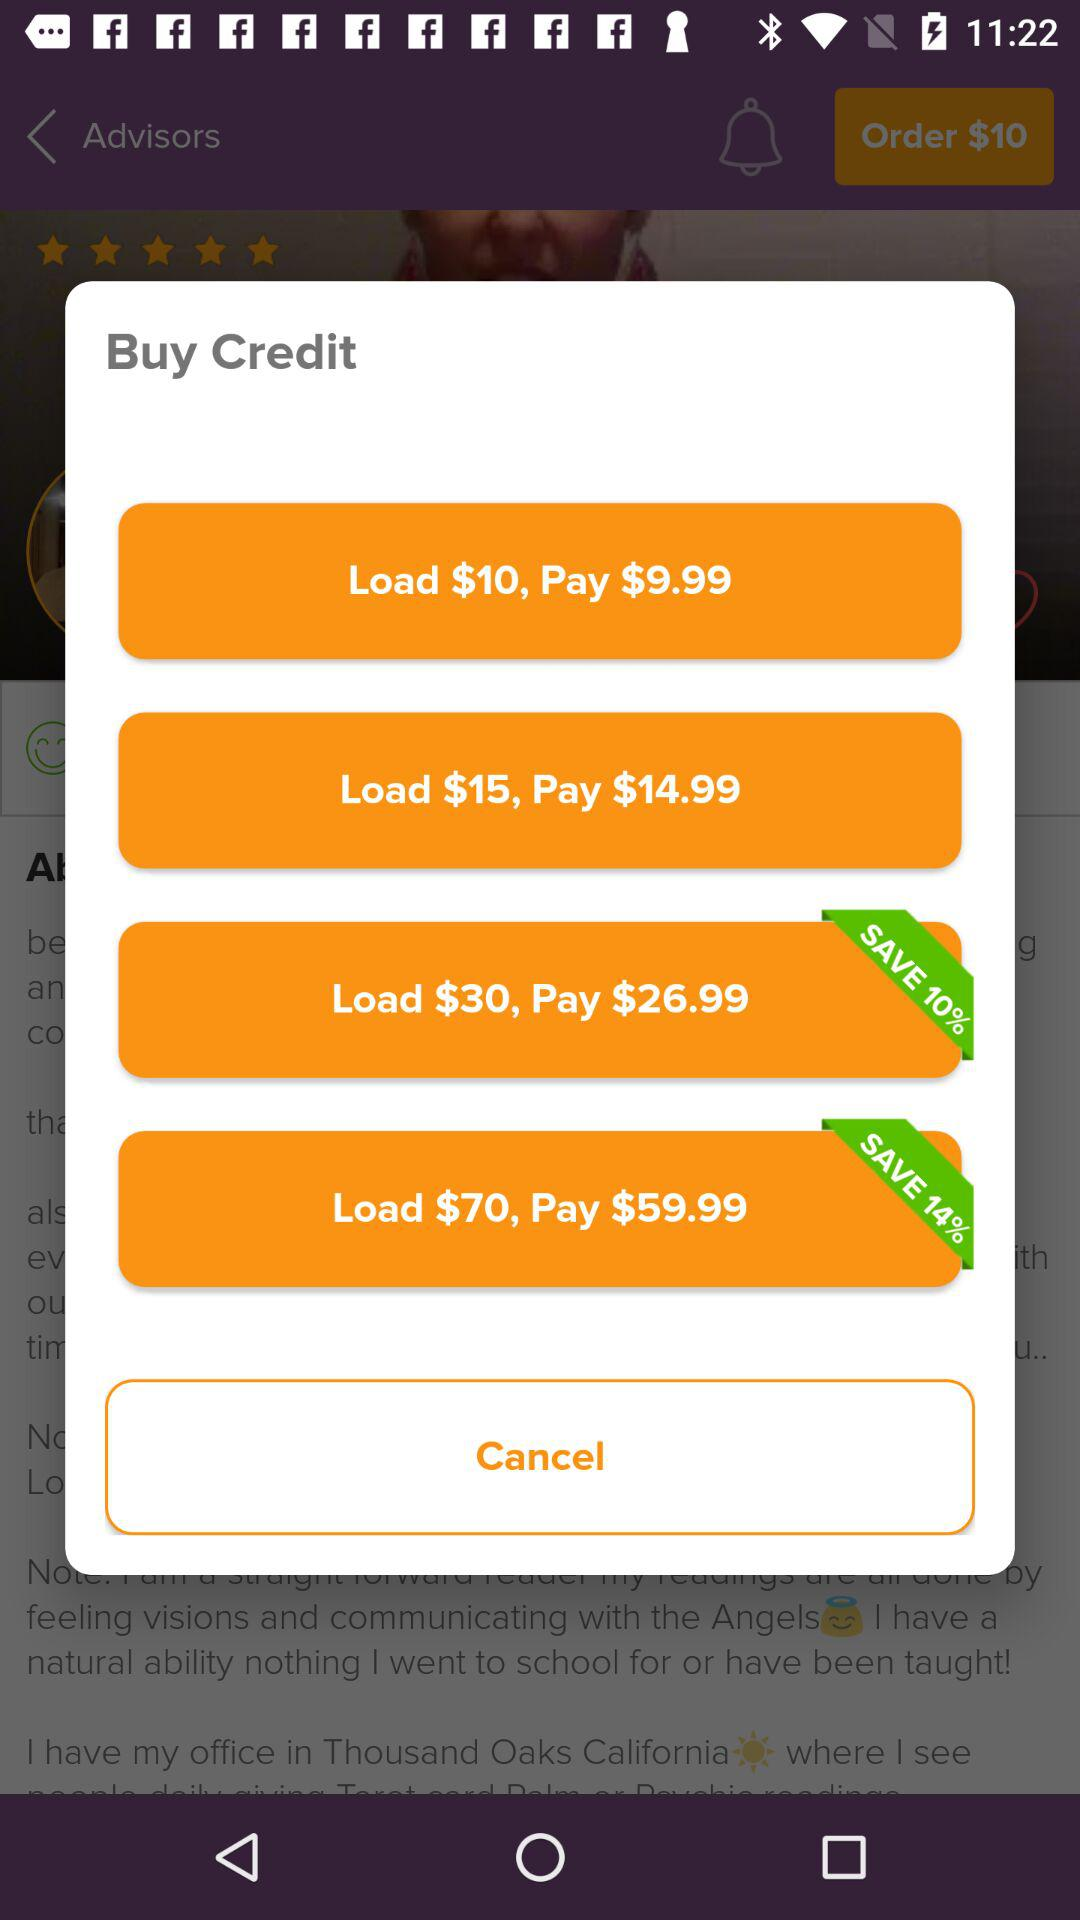How much discount is given on the load of $70? The given discount is 14%. 